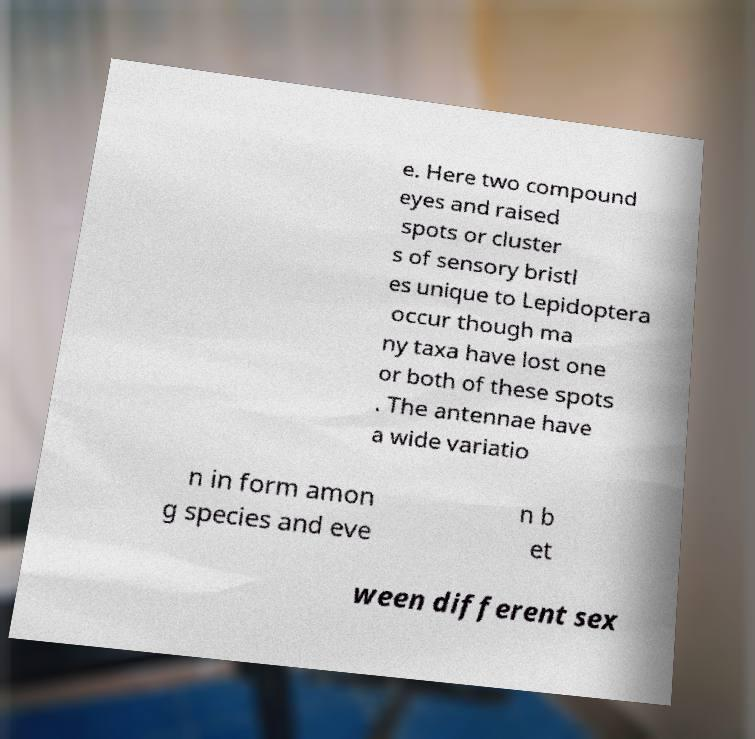For documentation purposes, I need the text within this image transcribed. Could you provide that? e. Here two compound eyes and raised spots or cluster s of sensory bristl es unique to Lepidoptera occur though ma ny taxa have lost one or both of these spots . The antennae have a wide variatio n in form amon g species and eve n b et ween different sex 